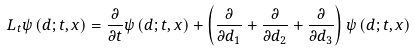<formula> <loc_0><loc_0><loc_500><loc_500>L _ { t } \psi \left ( { d ; t , x } \right ) = \frac { \partial } { \partial t } \psi \left ( { d ; t , x } \right ) + \left ( { \frac { \partial } { \partial d _ { 1 } } + \frac { \partial } { \partial d _ { 2 } } + \frac { \partial } { \partial d _ { 3 } } } \right ) \psi \left ( { d ; t , x } \right )</formula> 